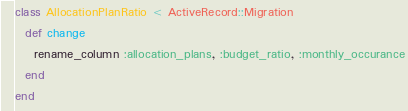<code> <loc_0><loc_0><loc_500><loc_500><_Ruby_>class AllocationPlanRatio < ActiveRecord::Migration
  def change
  	rename_column :allocation_plans, :budget_ratio, :monthly_occurance
  end
end
</code> 